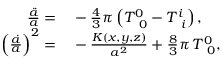Convert formula to latex. <formula><loc_0><loc_0><loc_500><loc_500>\begin{array} { r l } { \frac { \ddot { a } } { a } = } & - \frac { 4 } { 3 } \pi \left ( T _ { \, 0 } ^ { 0 } - T _ { \, i } ^ { i } \right ) , } \\ { \left ( \frac { \dot { a } } { a } \right ) ^ { 2 } = } & - \frac { K \left ( x , y , z \right ) } { a ^ { 2 } } + \frac { 8 } { 3 } \pi \, T _ { \, 0 } ^ { 0 } , } \end{array}</formula> 